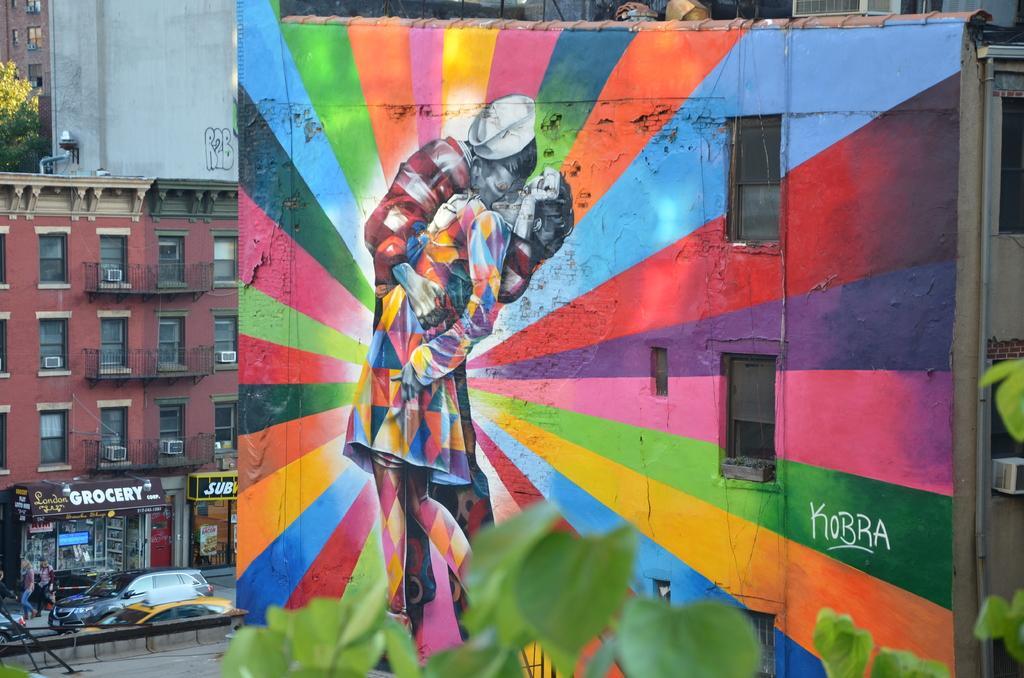Could you give a brief overview of what you see in this image? This is an outside view. Here I can see a wall on which there is a painting of two persons. At the bottom of the image I can see the leaves. In the background there are some buildings. On the left side, I can see few cars on the road and also few people are working. 